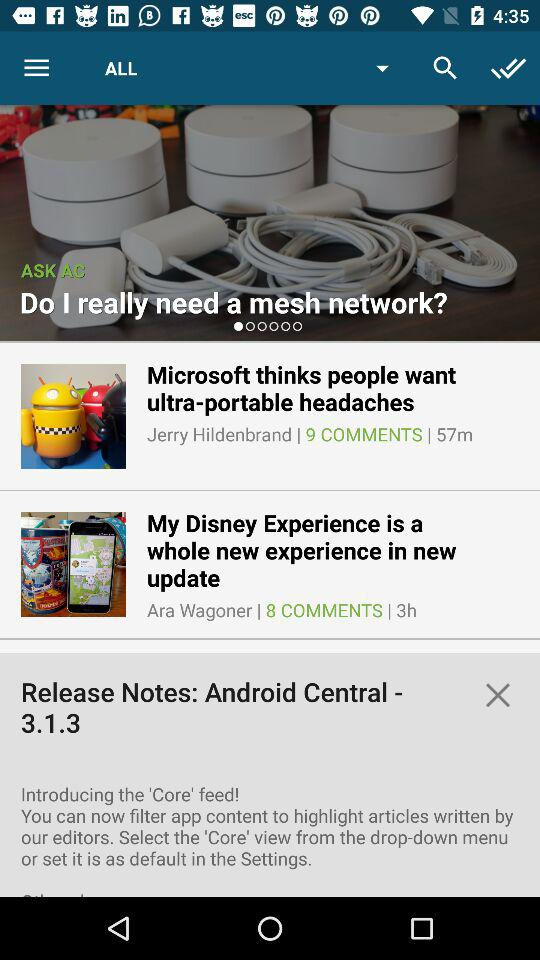How many comments are there for the post "My Disney Experience"? There are 8 comments for the post "My Disney Experience". 